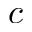Convert formula to latex. <formula><loc_0><loc_0><loc_500><loc_500>c</formula> 